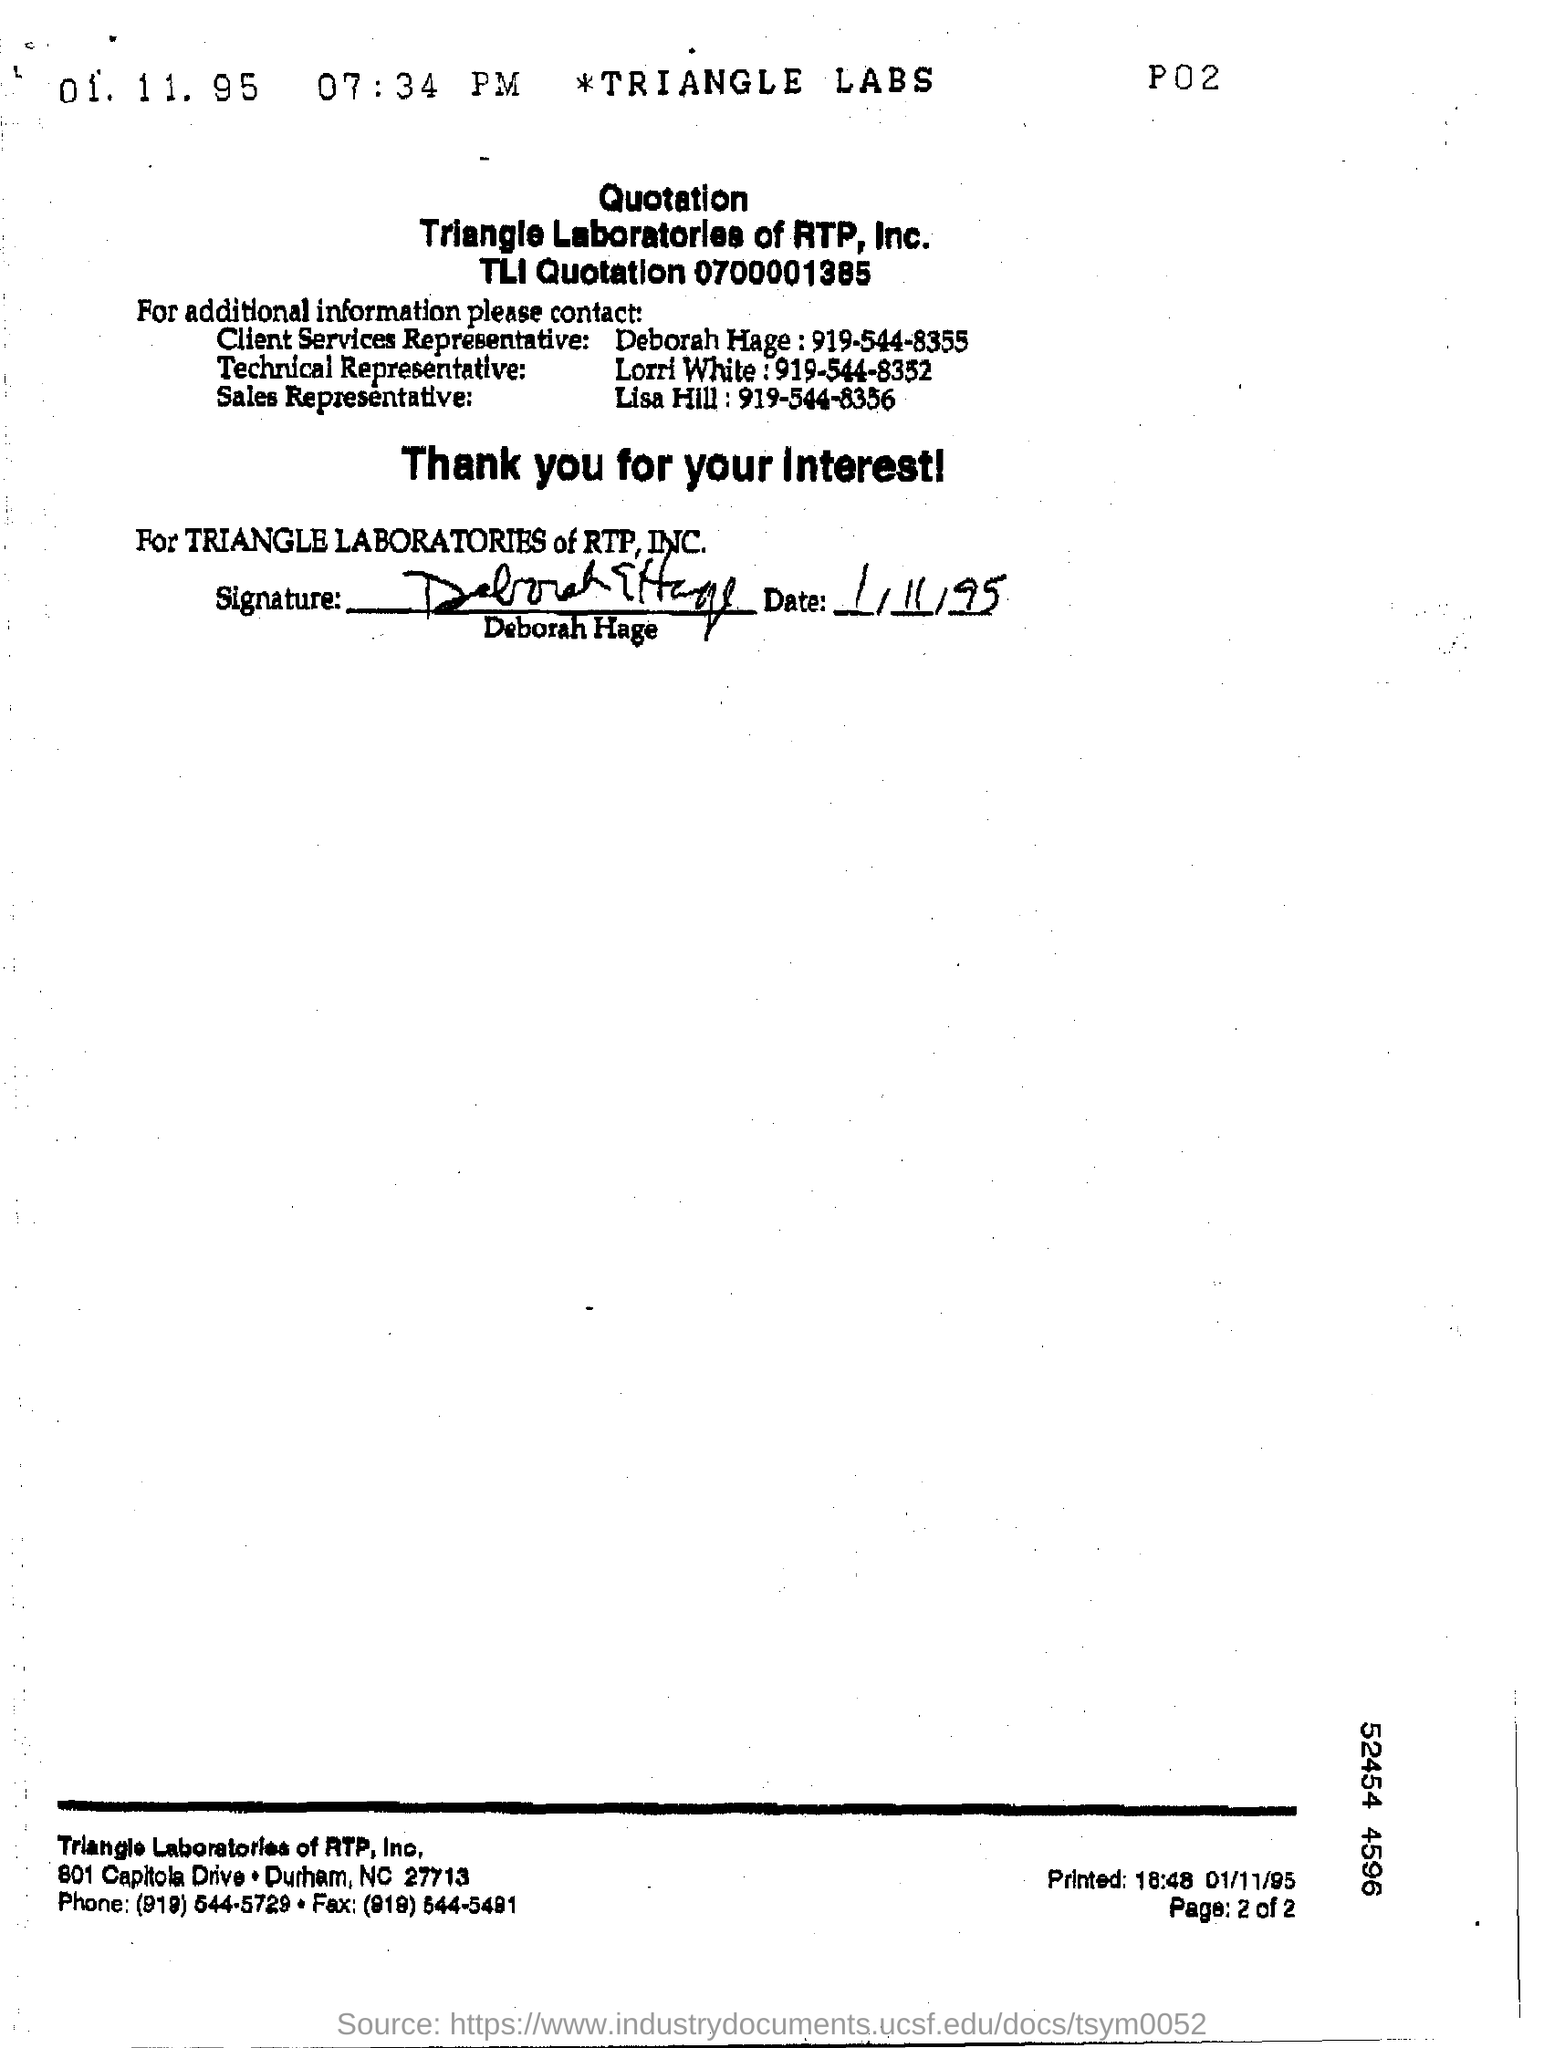Who is the client Services Representative ?
Keep it short and to the point. Deborah Hage. Who is the Technical representative ?
Make the answer very short. Lorri White. Who is the sales representative ?
Keep it short and to the point. Lisa Hill. Which company has sent the quotation?
Provide a short and direct response. Triangle Laboratories of RTP, Inc. 